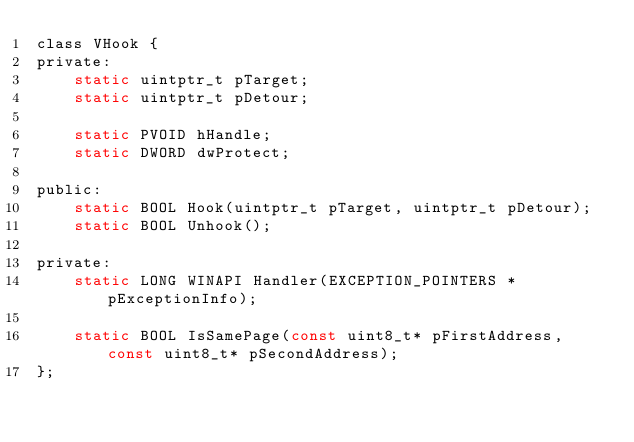<code> <loc_0><loc_0><loc_500><loc_500><_C_>class VHook {
private:
	static uintptr_t pTarget;
	static uintptr_t pDetour;

	static PVOID hHandle;
	static DWORD dwProtect;

public:
	static BOOL Hook(uintptr_t pTarget, uintptr_t pDetour);
	static BOOL Unhook();

private:
	static LONG WINAPI Handler(EXCEPTION_POINTERS *pExceptionInfo);

	static BOOL IsSamePage(const uint8_t* pFirstAddress, const uint8_t* pSecondAddress);
};
</code> 